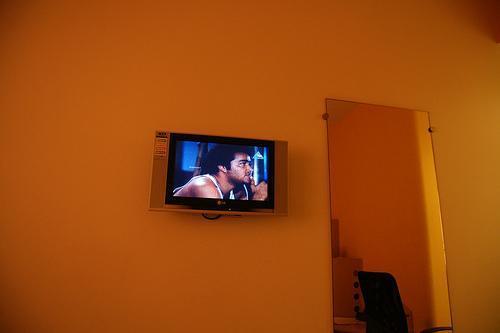How many prints are on the wall?
Give a very brief answer. 0. How many TV screens are in the picture?
Give a very brief answer. 1. How many buses are there?
Give a very brief answer. 0. 